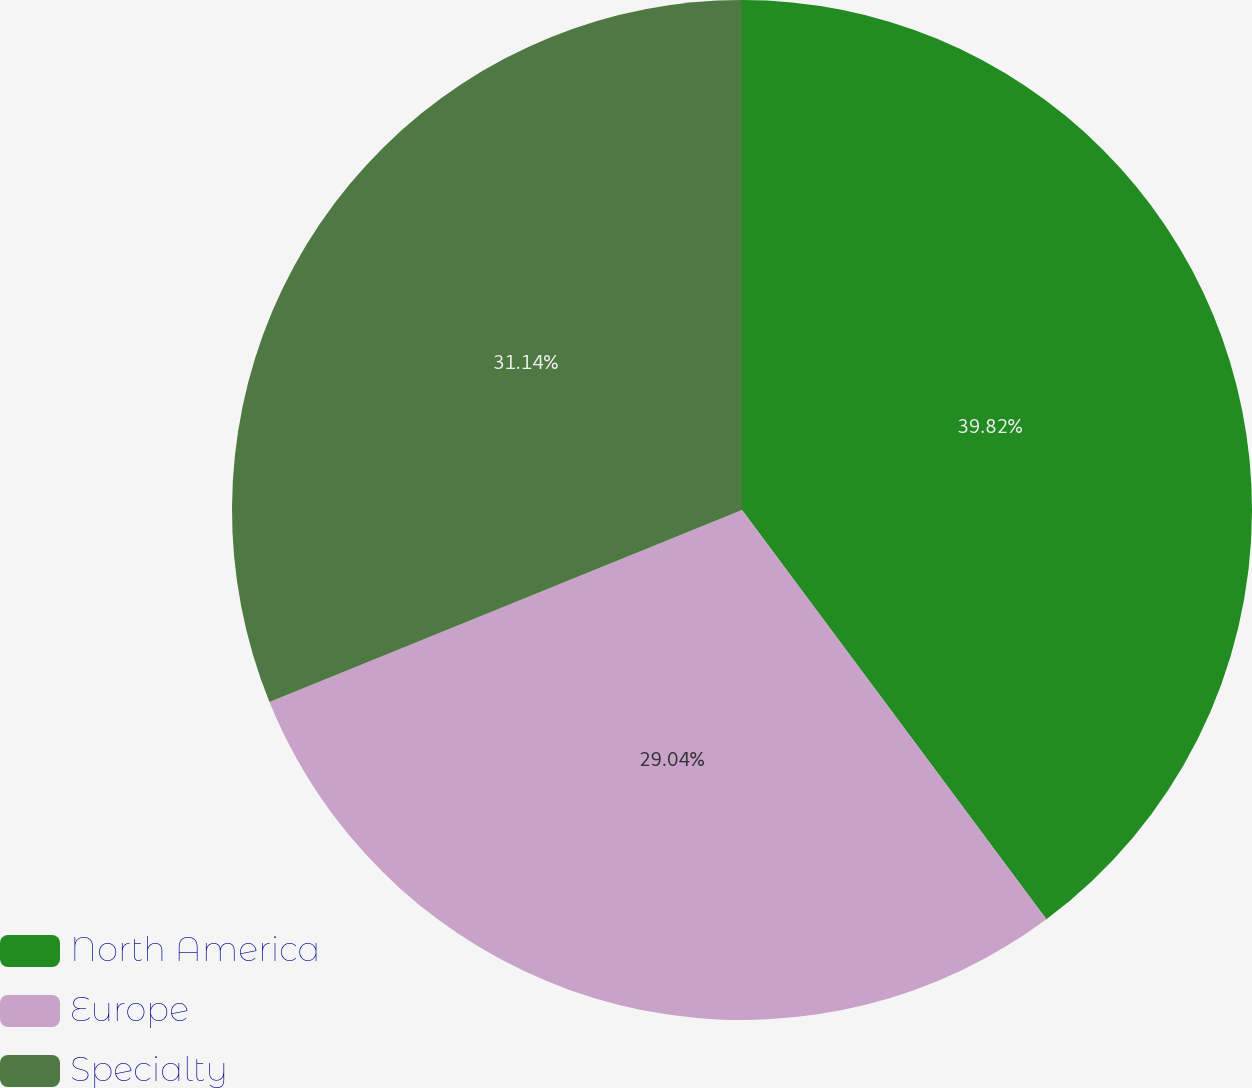Convert chart to OTSL. <chart><loc_0><loc_0><loc_500><loc_500><pie_chart><fcel>North America<fcel>Europe<fcel>Specialty<nl><fcel>39.82%<fcel>29.04%<fcel>31.14%<nl></chart> 